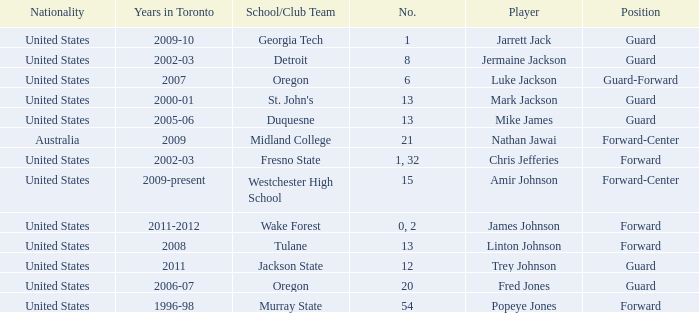What school/club team is Trey Johnson on? Jackson State. 